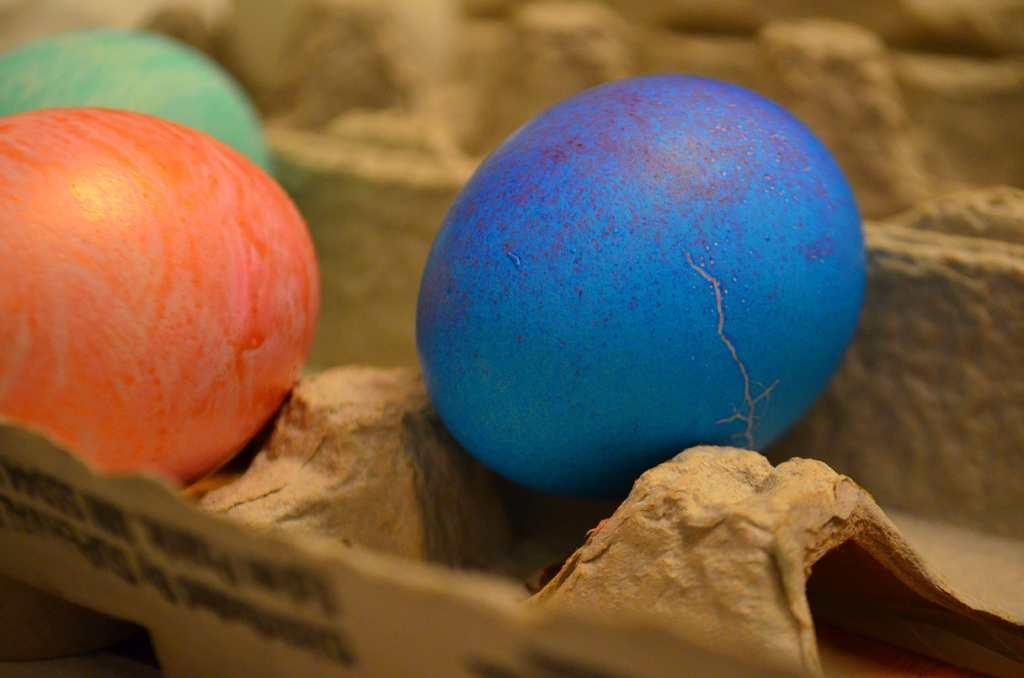How many eggs are visible in the image? There are three eggs in the image. What colors are the eggs? The eggs are in green, orange, and blue colors. Where are the eggs placed? The eggs are placed on an egg tray. What type of veil can be seen covering the snails in the image? There are no snails or veils present in the image; it features three eggs in different colors placed on an egg tray. 